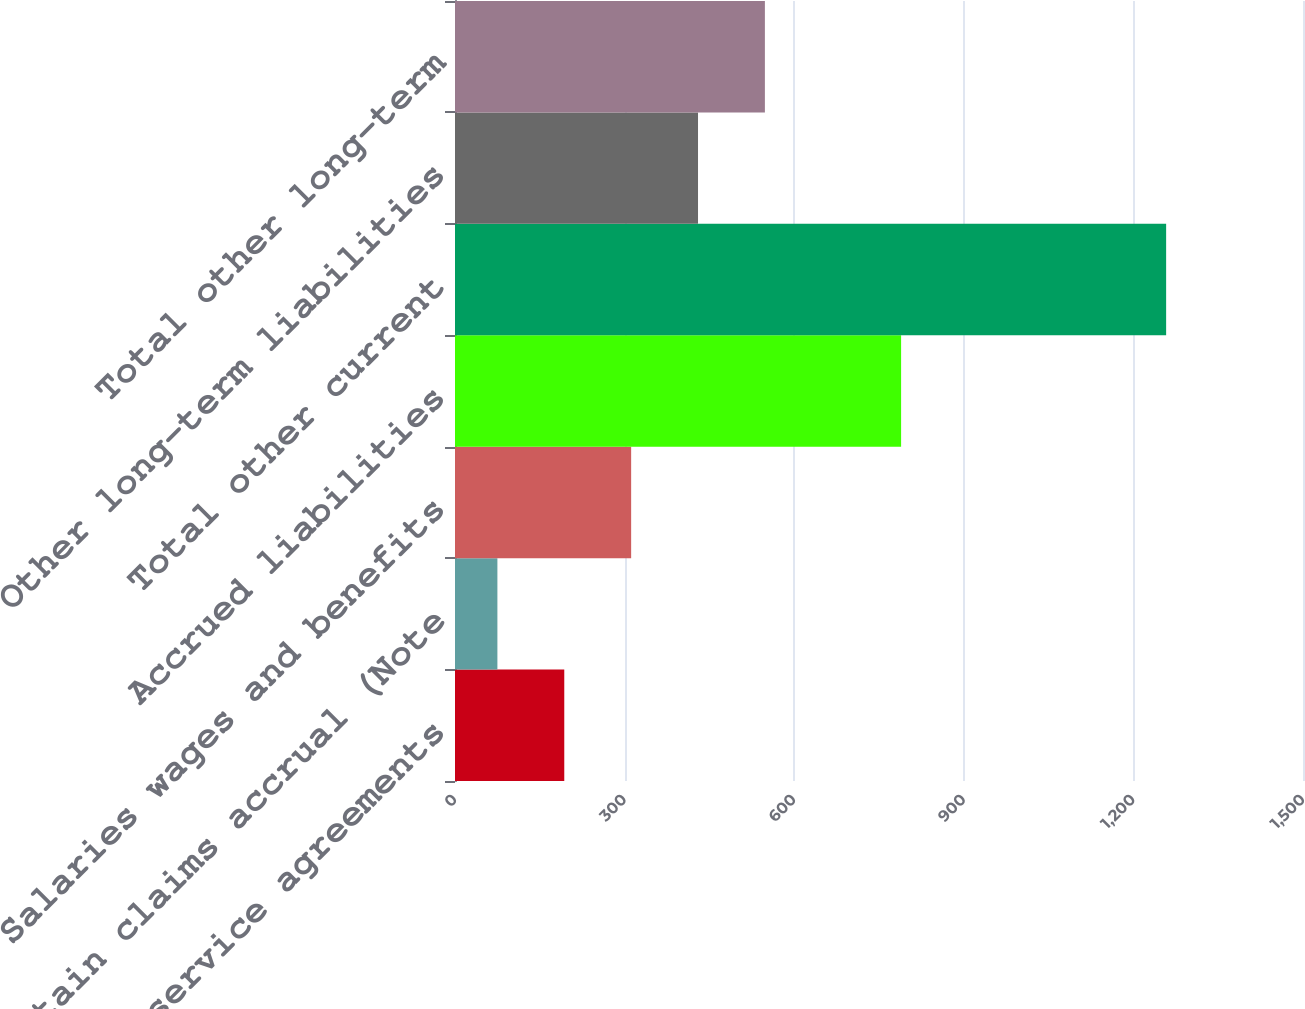Convert chart. <chart><loc_0><loc_0><loc_500><loc_500><bar_chart><fcel>License and service agreements<fcel>Certain claims accrual (Note<fcel>Salaries wages and benefits<fcel>Accrued liabilities<fcel>Total other current<fcel>Other long-term liabilities<fcel>Total other long-term<nl><fcel>193.29<fcel>75<fcel>311.58<fcel>789.1<fcel>1257.9<fcel>429.87<fcel>548.16<nl></chart> 